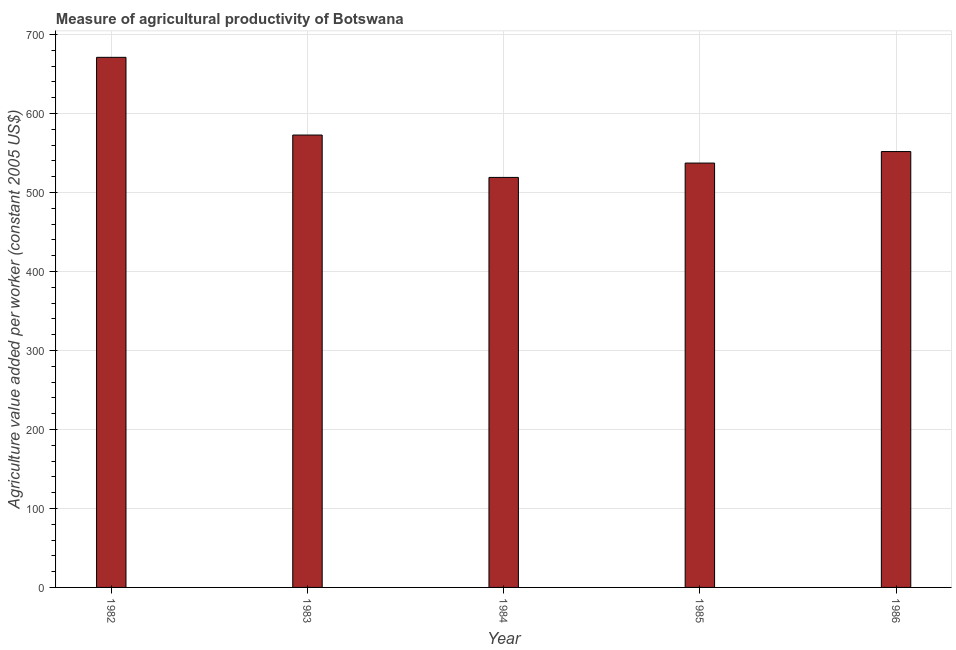What is the title of the graph?
Your answer should be very brief. Measure of agricultural productivity of Botswana. What is the label or title of the Y-axis?
Your answer should be very brief. Agriculture value added per worker (constant 2005 US$). What is the agriculture value added per worker in 1986?
Your answer should be compact. 551.87. Across all years, what is the maximum agriculture value added per worker?
Ensure brevity in your answer.  671.18. Across all years, what is the minimum agriculture value added per worker?
Your response must be concise. 519.13. In which year was the agriculture value added per worker maximum?
Make the answer very short. 1982. In which year was the agriculture value added per worker minimum?
Keep it short and to the point. 1984. What is the sum of the agriculture value added per worker?
Give a very brief answer. 2852.26. What is the difference between the agriculture value added per worker in 1982 and 1985?
Provide a succinct answer. 133.88. What is the average agriculture value added per worker per year?
Give a very brief answer. 570.45. What is the median agriculture value added per worker?
Make the answer very short. 551.87. In how many years, is the agriculture value added per worker greater than 420 US$?
Offer a terse response. 5. Do a majority of the years between 1982 and 1983 (inclusive) have agriculture value added per worker greater than 340 US$?
Your response must be concise. Yes. What is the ratio of the agriculture value added per worker in 1982 to that in 1986?
Offer a very short reply. 1.22. Is the agriculture value added per worker in 1982 less than that in 1986?
Give a very brief answer. No. What is the difference between the highest and the second highest agriculture value added per worker?
Provide a succinct answer. 98.4. What is the difference between the highest and the lowest agriculture value added per worker?
Provide a succinct answer. 152.05. In how many years, is the agriculture value added per worker greater than the average agriculture value added per worker taken over all years?
Provide a short and direct response. 2. Are all the bars in the graph horizontal?
Offer a very short reply. No. How many years are there in the graph?
Provide a short and direct response. 5. Are the values on the major ticks of Y-axis written in scientific E-notation?
Your answer should be compact. No. What is the Agriculture value added per worker (constant 2005 US$) of 1982?
Give a very brief answer. 671.18. What is the Agriculture value added per worker (constant 2005 US$) of 1983?
Ensure brevity in your answer.  572.78. What is the Agriculture value added per worker (constant 2005 US$) of 1984?
Your response must be concise. 519.13. What is the Agriculture value added per worker (constant 2005 US$) of 1985?
Offer a very short reply. 537.3. What is the Agriculture value added per worker (constant 2005 US$) of 1986?
Give a very brief answer. 551.87. What is the difference between the Agriculture value added per worker (constant 2005 US$) in 1982 and 1983?
Make the answer very short. 98.4. What is the difference between the Agriculture value added per worker (constant 2005 US$) in 1982 and 1984?
Your answer should be compact. 152.05. What is the difference between the Agriculture value added per worker (constant 2005 US$) in 1982 and 1985?
Keep it short and to the point. 133.88. What is the difference between the Agriculture value added per worker (constant 2005 US$) in 1982 and 1986?
Provide a short and direct response. 119.31. What is the difference between the Agriculture value added per worker (constant 2005 US$) in 1983 and 1984?
Your response must be concise. 53.65. What is the difference between the Agriculture value added per worker (constant 2005 US$) in 1983 and 1985?
Offer a terse response. 35.48. What is the difference between the Agriculture value added per worker (constant 2005 US$) in 1983 and 1986?
Provide a short and direct response. 20.91. What is the difference between the Agriculture value added per worker (constant 2005 US$) in 1984 and 1985?
Keep it short and to the point. -18.17. What is the difference between the Agriculture value added per worker (constant 2005 US$) in 1984 and 1986?
Offer a terse response. -32.74. What is the difference between the Agriculture value added per worker (constant 2005 US$) in 1985 and 1986?
Offer a terse response. -14.57. What is the ratio of the Agriculture value added per worker (constant 2005 US$) in 1982 to that in 1983?
Offer a terse response. 1.17. What is the ratio of the Agriculture value added per worker (constant 2005 US$) in 1982 to that in 1984?
Your response must be concise. 1.29. What is the ratio of the Agriculture value added per worker (constant 2005 US$) in 1982 to that in 1985?
Provide a succinct answer. 1.25. What is the ratio of the Agriculture value added per worker (constant 2005 US$) in 1982 to that in 1986?
Offer a very short reply. 1.22. What is the ratio of the Agriculture value added per worker (constant 2005 US$) in 1983 to that in 1984?
Keep it short and to the point. 1.1. What is the ratio of the Agriculture value added per worker (constant 2005 US$) in 1983 to that in 1985?
Offer a very short reply. 1.07. What is the ratio of the Agriculture value added per worker (constant 2005 US$) in 1983 to that in 1986?
Give a very brief answer. 1.04. What is the ratio of the Agriculture value added per worker (constant 2005 US$) in 1984 to that in 1986?
Your answer should be very brief. 0.94. 